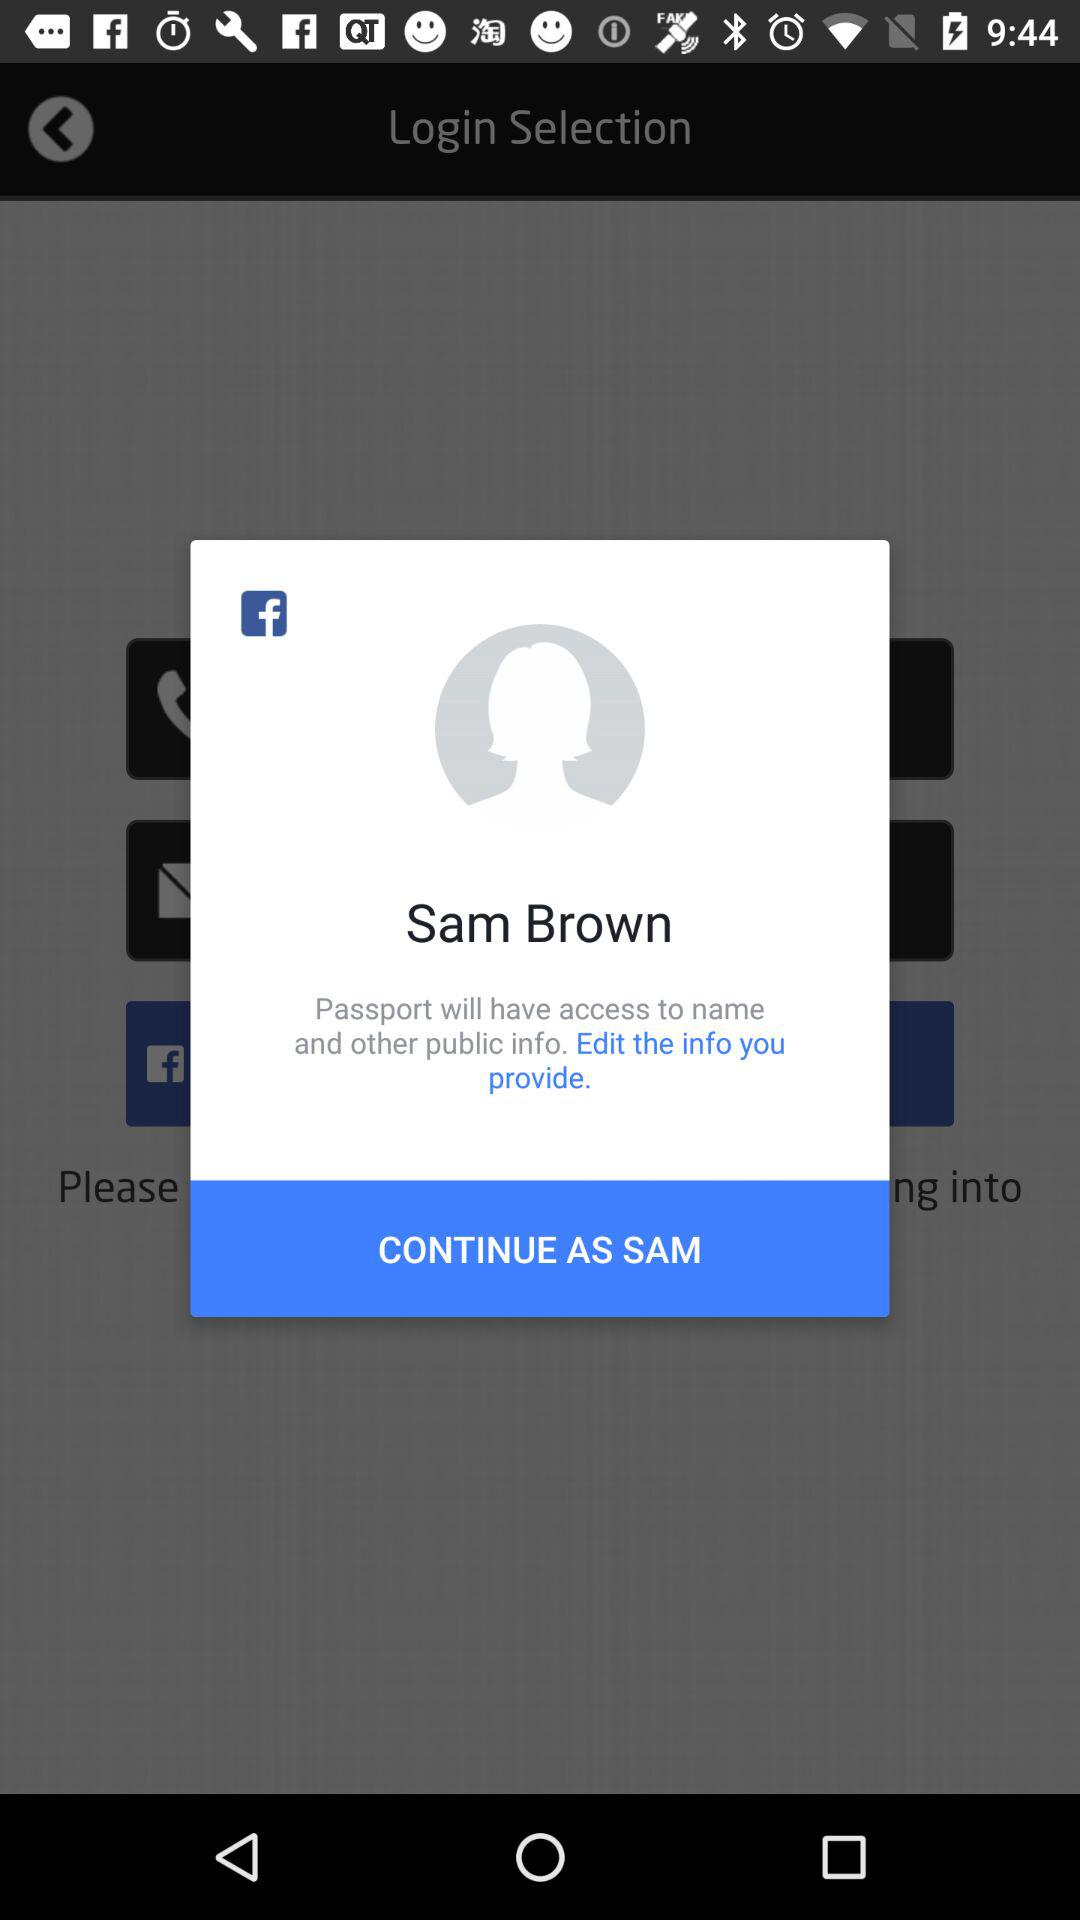What is the user name? The user name is Sam Brown. 